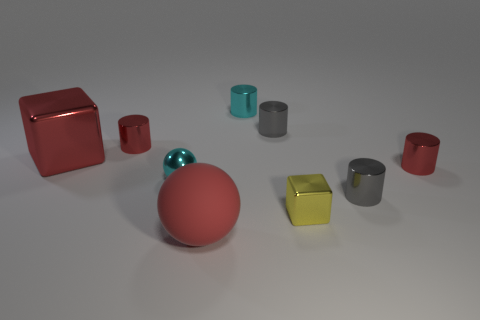Subtract all small cyan cylinders. How many cylinders are left? 4 Subtract all cyan blocks. How many red cylinders are left? 2 Add 1 tiny gray objects. How many objects exist? 10 Subtract all cyan cylinders. How many cylinders are left? 4 Subtract 1 cylinders. How many cylinders are left? 4 Subtract all cylinders. How many objects are left? 4 Subtract all brown cylinders. Subtract all red balls. How many cylinders are left? 5 Subtract all big yellow shiny balls. Subtract all cylinders. How many objects are left? 4 Add 8 big red balls. How many big red balls are left? 9 Add 4 metal cylinders. How many metal cylinders exist? 9 